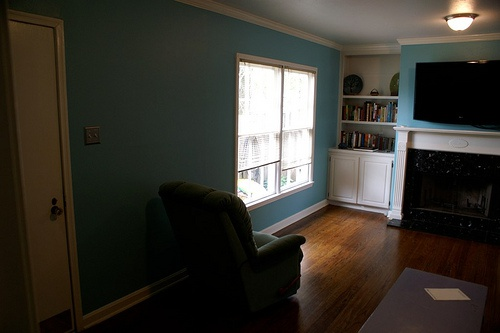Describe the objects in this image and their specific colors. I can see chair in black, gray, and purple tones, couch in black and gray tones, tv in black, blue, darkblue, and teal tones, book in black, gray, and maroon tones, and book in black, purple, and darkblue tones in this image. 